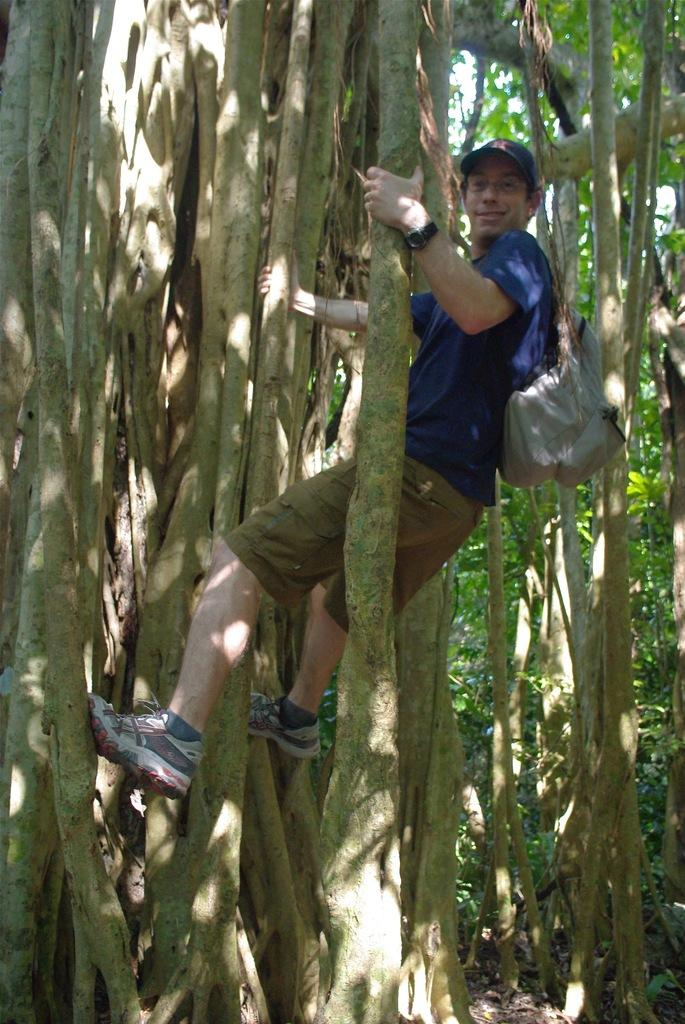Who is the main subject in the image? There is a man in the image. What is the man doing in the image? The man is climbing a tree. What is the man wearing on his back? The man is wearing a bag. What is the man wearing on his head? The man is wearing a cap. What type of zebra can be seen on the man's cap in the image? There is no zebra present on the man's cap in the image. What is the man's temper like while climbing the tree? The image does not provide any information about the man's temper, so it cannot be determined from the image. 